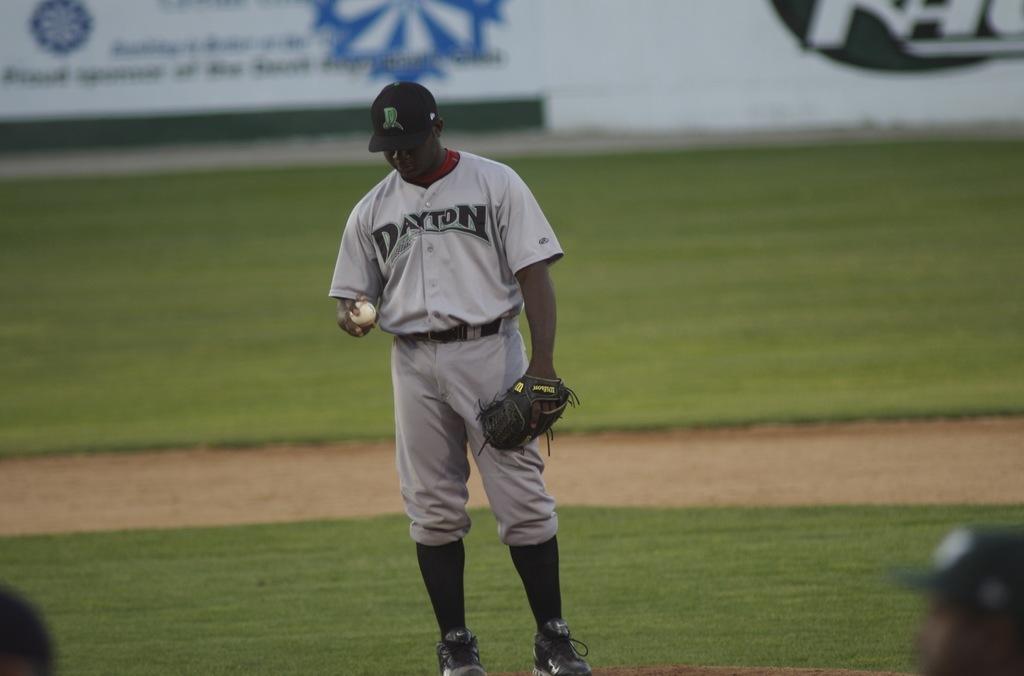What is the name of the team?
Make the answer very short. Dayton. What is written on the player's shirt?
Make the answer very short. Dayton. 